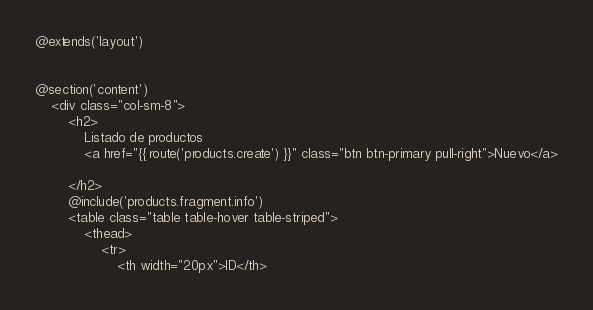<code> <loc_0><loc_0><loc_500><loc_500><_PHP_>@extends('layout')


@section('content')
	<div class="col-sm-8">
		<h2>
			Listado de productos
			<a href="{{ route('products.create') }}" class="btn btn-primary pull-right">Nuevo</a>

		</h2>
		@include('products.fragment.info')
		<table class="table table-hover table-striped">
			<thead>
				<tr>
					<th width="20px">ID</th> </code> 